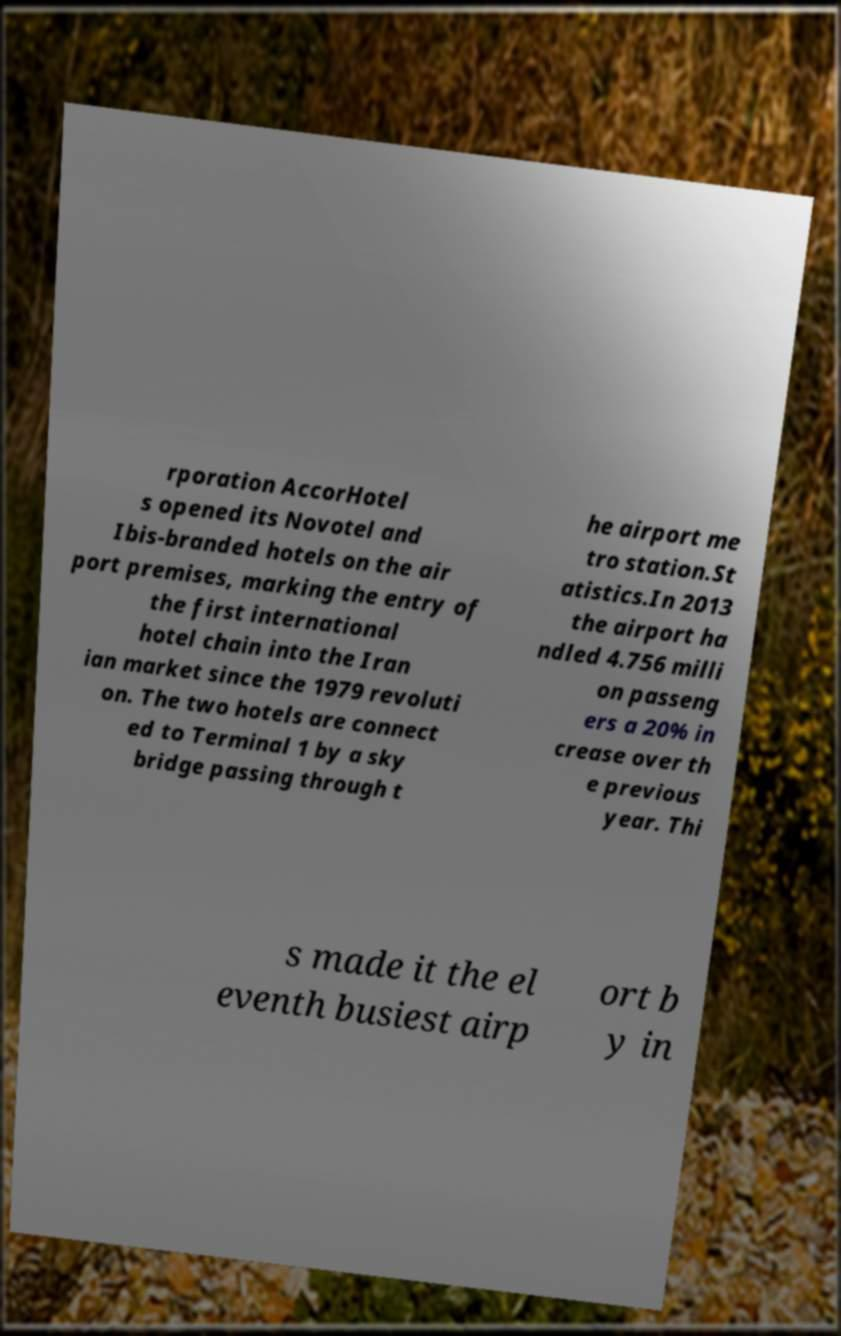Can you accurately transcribe the text from the provided image for me? rporation AccorHotel s opened its Novotel and Ibis-branded hotels on the air port premises, marking the entry of the first international hotel chain into the Iran ian market since the 1979 revoluti on. The two hotels are connect ed to Terminal 1 by a sky bridge passing through t he airport me tro station.St atistics.In 2013 the airport ha ndled 4.756 milli on passeng ers a 20% in crease over th e previous year. Thi s made it the el eventh busiest airp ort b y in 